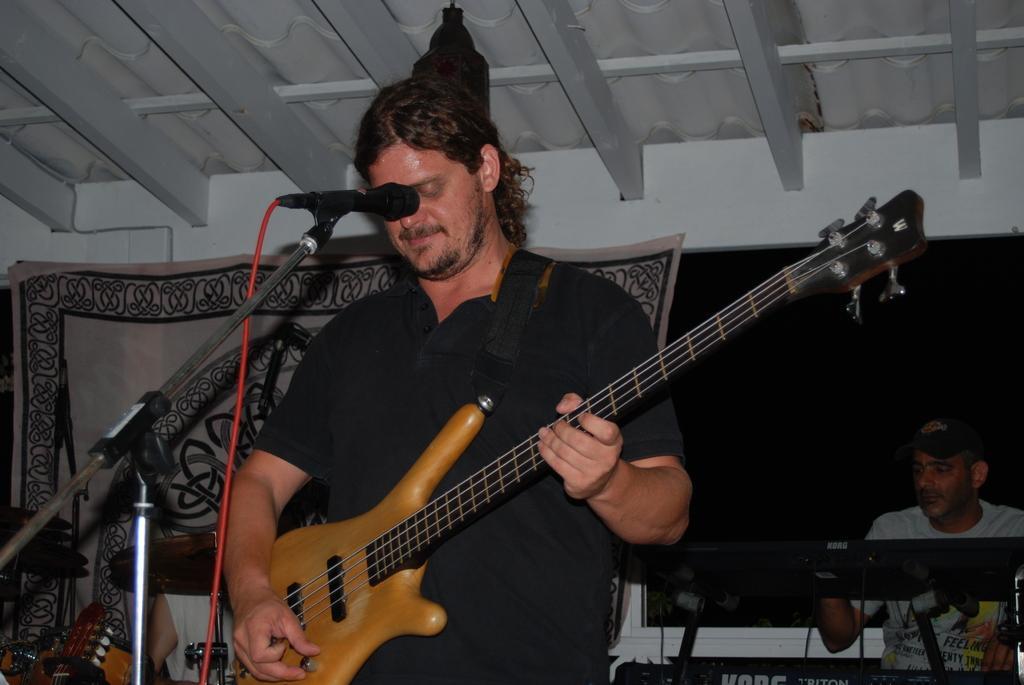Please provide a concise description of this image. In this picture we can see a man standing and playing a guitar, there is a microphone in front of him, on the right side there is a person sitting, on the left side we can see a cymbal, in the background there is a cloth. 